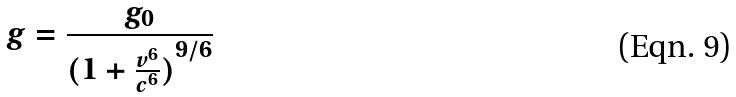<formula> <loc_0><loc_0><loc_500><loc_500>g = \frac { g _ { 0 } } { ( { 1 + \frac { v ^ { 6 } } { c ^ { 6 } } ) } ^ { 9 / 6 } }</formula> 